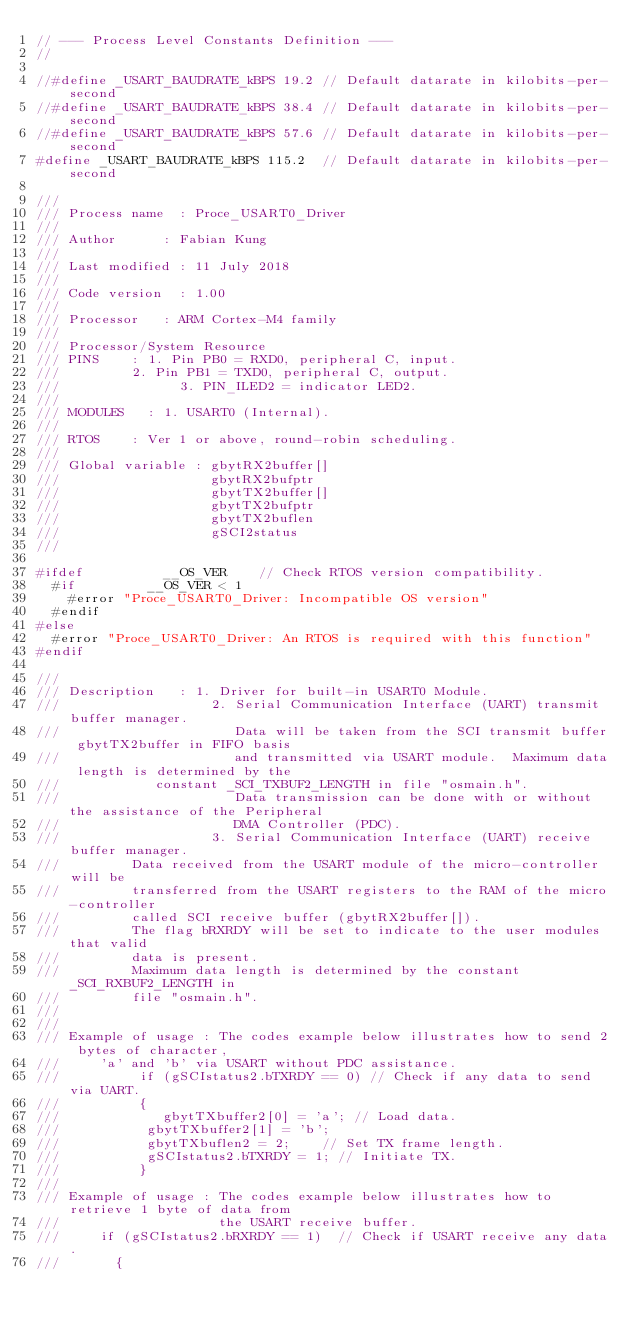<code> <loc_0><loc_0><loc_500><loc_500><_C_>// --- Process Level Constants Definition --- 
//

//#define	_USART_BAUDRATE_kBPS 19.2	// Default datarate in kilobits-per-second
//#define	_USART_BAUDRATE_kBPS 38.4	// Default datarate in kilobits-per-second
//#define	_USART_BAUDRATE_kBPS 57.6	// Default datarate in kilobits-per-second
#define	_USART_BAUDRATE_kBPS 115.2	// Default datarate in kilobits-per-second

///
/// Process name	: Proce_USART0_Driver
///
/// Author			: Fabian Kung
///
/// Last modified	: 11 July 2018
///
/// Code version	: 1.00
///
/// Processor		: ARM Cortex-M4 family                   
///
/// Processor/System Resource 
/// PINS		: 1. Pin PB0 = RXD0, peripheral C, input.
///  			  2. Pin PB1 = TXD0, peripheral C, output.
///               3. PIN_ILED2 = indicator LED2.
///
/// MODULES		: 1. USART0 (Internal).
///
/// RTOS		: Ver 1 or above, round-robin scheduling.
///
/// Global variable	: gbytRX2buffer[]
///                   gbytRX2bufptr
///                   gbytTX2buffer[]
///                   gbytTX2bufptr
///                   gbytTX2buflen
///                   gSCI2status
///

#ifdef 				  __OS_VER		// Check RTOS version compatibility.
	#if 			  __OS_VER < 1
		#error "Proce_USART0_Driver: Incompatible OS version"
	#endif
#else
	#error "Proce_USART0_Driver: An RTOS is required with this function"
#endif

///
/// Description		: 1. Driver for built-in USART0 Module.
///                   2. Serial Communication Interface (UART) transmit buffer manager.
///                      Data will be taken from the SCI transmit buffer gbytTX2buffer in FIFO basis
///                      and transmitted via USART module.  Maximum data length is determined by the
///						 constant _SCI_TXBUF2_LENGTH in file "osmain.h".
///                      Data transmission can be done with or without the assistance of the Peripheral
///                      DMA Controller (PDC).
///                   3. Serial Communication Interface (UART) receive buffer manager.
///					Data received from the USART module of the micro-controller will be
///					transferred from the USART registers to the RAM of the micro-controller
///					called SCI receive buffer (gbytRX2buffer[]).
///					The flag bRXRDY will be set to indicate to the user modules that valid
///					data is present.
///					Maximum data length is determined by the constant _SCI_RXBUF2_LENGTH in
///					file "osmain.h".
///
///
/// Example of usage : The codes example below illustrates how to send 2 bytes of character,
///			'a' and 'b' via USART without PDC assistance.
///          if (gSCIstatus2.bTXRDY == 0)	// Check if any data to send via UART.
///          {
///             gbytTXbuffer2[0] = 'a';	// Load data.
///		   	    gbytTXbuffer2[1] = 'b';
///		   	    gbytTXbuflen2 = 2;		// Set TX frame length.
///		  	    gSCIstatus2.bTXRDY = 1;	// Initiate TX.
///          }
///
/// Example of usage : The codes example below illustrates how to retrieve 1 byte of data from
///                    the USART receive buffer.
///			if (gSCIstatus2.bRXRDY == 1)	// Check if USART receive any data.
///		    {</code> 